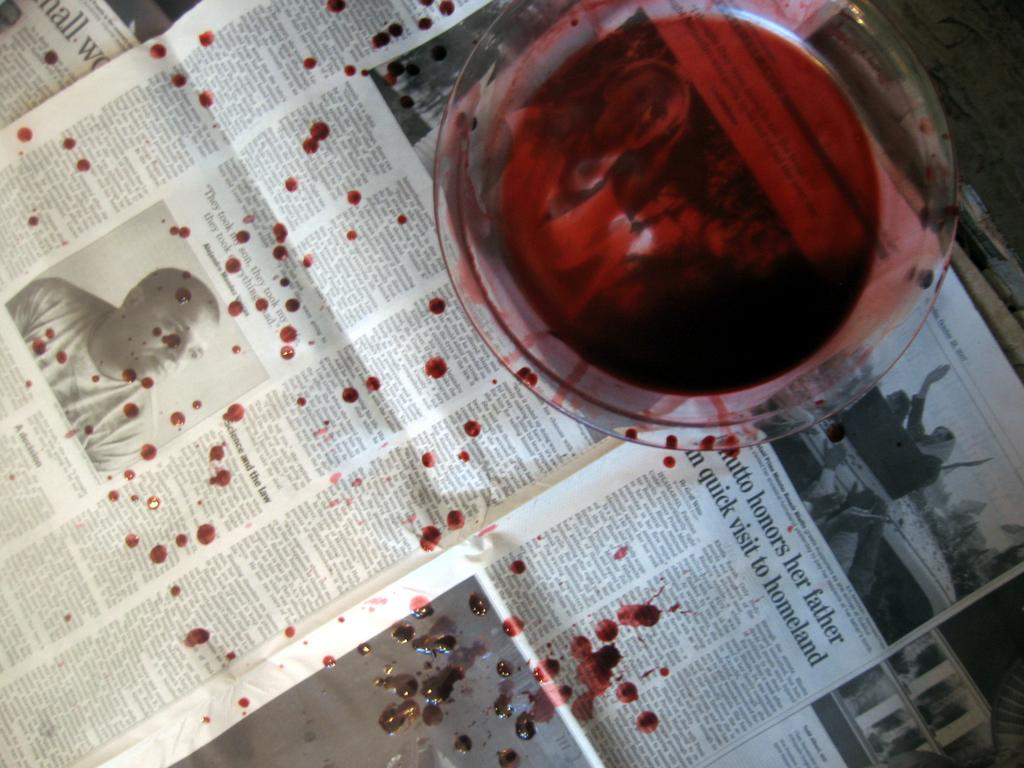<image>
Share a concise interpretation of the image provided. A glass of red wine has spilled on a paper with an article about someone honouring their father. 